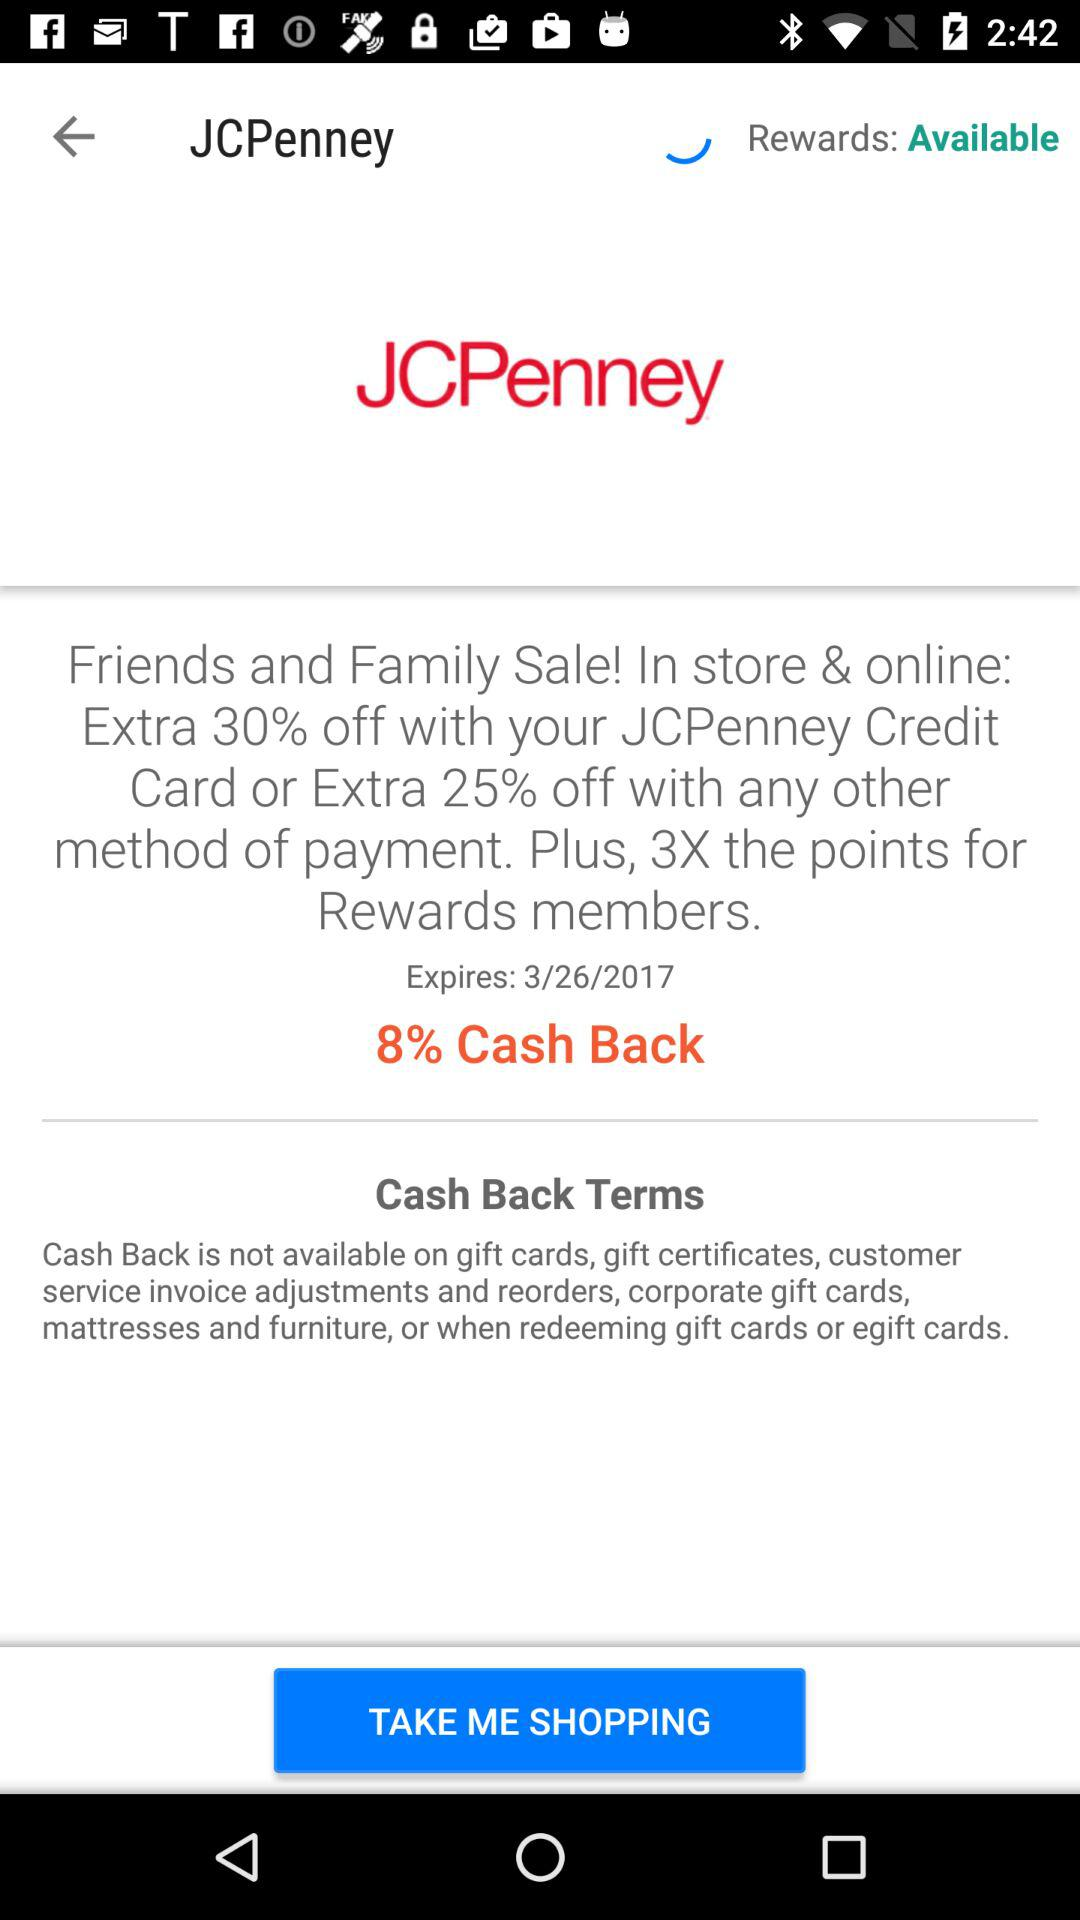How much of a discount is there while using a "JCPenney credit card" in store? There is a discount of extra 30%. 